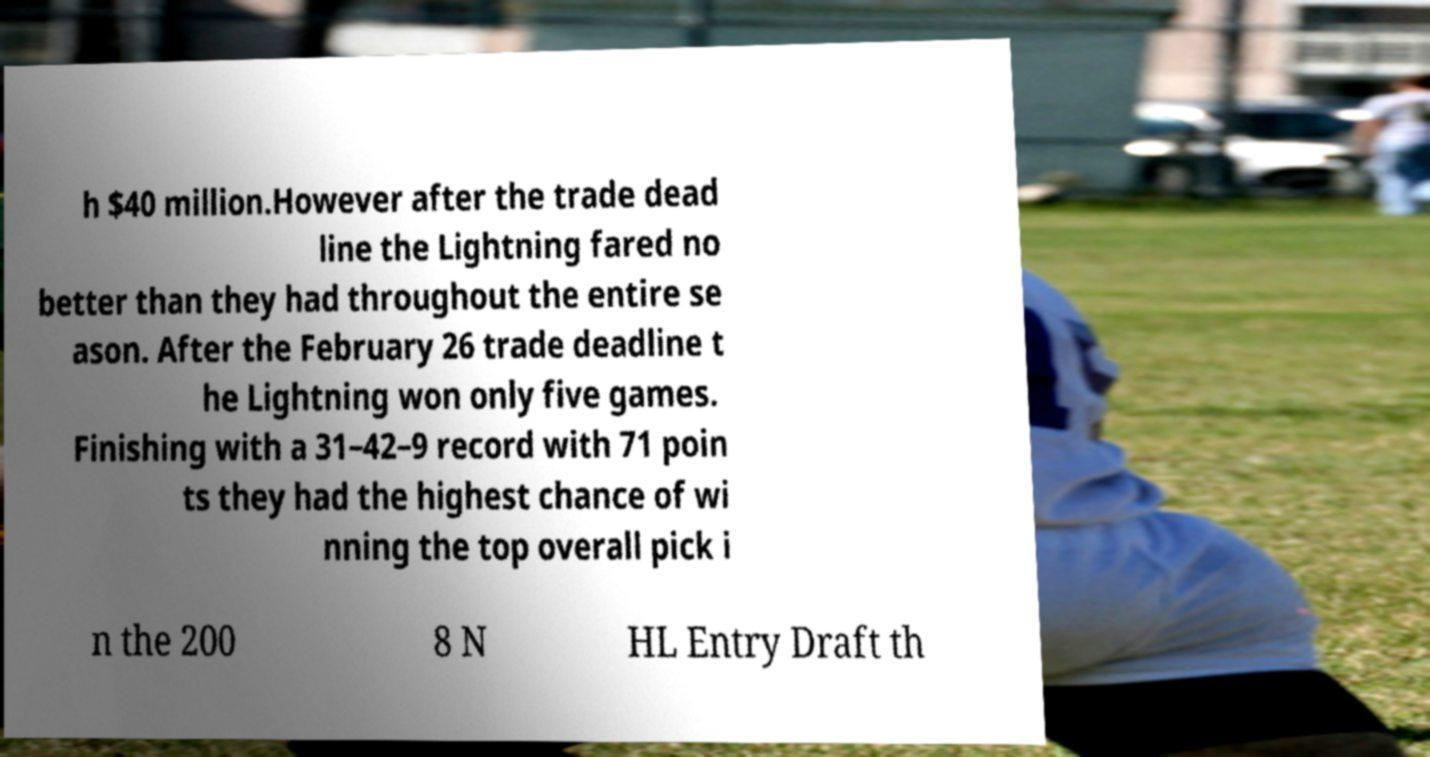What messages or text are displayed in this image? I need them in a readable, typed format. h $40 million.However after the trade dead line the Lightning fared no better than they had throughout the entire se ason. After the February 26 trade deadline t he Lightning won only five games. Finishing with a 31–42–9 record with 71 poin ts they had the highest chance of wi nning the top overall pick i n the 200 8 N HL Entry Draft th 